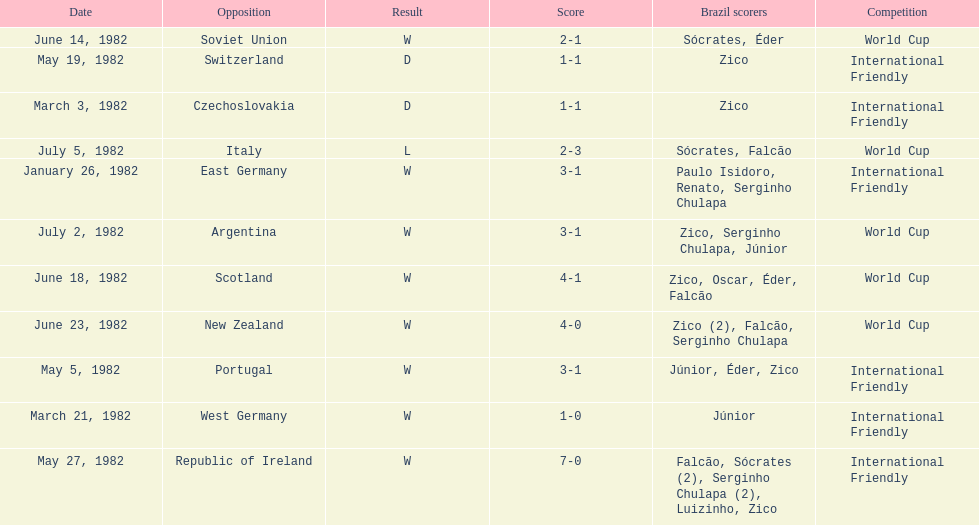How many games did this team play in 1982? 11. 